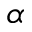Convert formula to latex. <formula><loc_0><loc_0><loc_500><loc_500>\alpha</formula> 